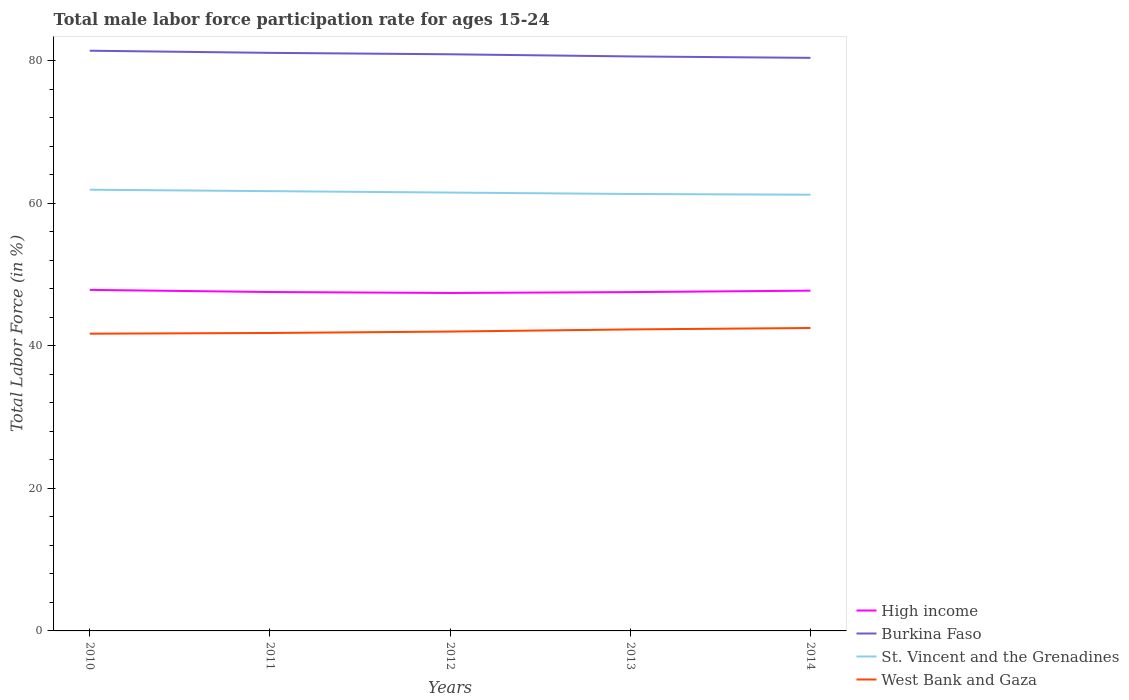Is the number of lines equal to the number of legend labels?
Keep it short and to the point. Yes. Across all years, what is the maximum male labor force participation rate in High income?
Provide a succinct answer. 47.41. In which year was the male labor force participation rate in St. Vincent and the Grenadines maximum?
Your answer should be very brief. 2014. What is the total male labor force participation rate in High income in the graph?
Provide a short and direct response. -0.19. What is the difference between the highest and the second highest male labor force participation rate in High income?
Keep it short and to the point. 0.44. What is the difference between the highest and the lowest male labor force participation rate in St. Vincent and the Grenadines?
Keep it short and to the point. 2. Is the male labor force participation rate in Burkina Faso strictly greater than the male labor force participation rate in High income over the years?
Offer a terse response. No. What is the difference between two consecutive major ticks on the Y-axis?
Keep it short and to the point. 20. Does the graph contain any zero values?
Your answer should be very brief. No. How many legend labels are there?
Your answer should be very brief. 4. What is the title of the graph?
Provide a succinct answer. Total male labor force participation rate for ages 15-24. Does "East Asia (developing only)" appear as one of the legend labels in the graph?
Your answer should be compact. No. What is the Total Labor Force (in %) in High income in 2010?
Offer a terse response. 47.85. What is the Total Labor Force (in %) of Burkina Faso in 2010?
Make the answer very short. 81.4. What is the Total Labor Force (in %) in St. Vincent and the Grenadines in 2010?
Provide a short and direct response. 61.9. What is the Total Labor Force (in %) of West Bank and Gaza in 2010?
Give a very brief answer. 41.7. What is the Total Labor Force (in %) in High income in 2011?
Provide a short and direct response. 47.55. What is the Total Labor Force (in %) of Burkina Faso in 2011?
Provide a succinct answer. 81.1. What is the Total Labor Force (in %) of St. Vincent and the Grenadines in 2011?
Make the answer very short. 61.7. What is the Total Labor Force (in %) of West Bank and Gaza in 2011?
Make the answer very short. 41.8. What is the Total Labor Force (in %) in High income in 2012?
Keep it short and to the point. 47.41. What is the Total Labor Force (in %) in Burkina Faso in 2012?
Your answer should be compact. 80.9. What is the Total Labor Force (in %) of St. Vincent and the Grenadines in 2012?
Make the answer very short. 61.5. What is the Total Labor Force (in %) of West Bank and Gaza in 2012?
Provide a short and direct response. 42. What is the Total Labor Force (in %) of High income in 2013?
Provide a short and direct response. 47.53. What is the Total Labor Force (in %) in Burkina Faso in 2013?
Provide a succinct answer. 80.6. What is the Total Labor Force (in %) of St. Vincent and the Grenadines in 2013?
Keep it short and to the point. 61.3. What is the Total Labor Force (in %) of West Bank and Gaza in 2013?
Your response must be concise. 42.3. What is the Total Labor Force (in %) in High income in 2014?
Keep it short and to the point. 47.74. What is the Total Labor Force (in %) in Burkina Faso in 2014?
Provide a succinct answer. 80.4. What is the Total Labor Force (in %) of St. Vincent and the Grenadines in 2014?
Your answer should be compact. 61.2. What is the Total Labor Force (in %) of West Bank and Gaza in 2014?
Offer a terse response. 42.5. Across all years, what is the maximum Total Labor Force (in %) in High income?
Ensure brevity in your answer.  47.85. Across all years, what is the maximum Total Labor Force (in %) in Burkina Faso?
Give a very brief answer. 81.4. Across all years, what is the maximum Total Labor Force (in %) of St. Vincent and the Grenadines?
Make the answer very short. 61.9. Across all years, what is the maximum Total Labor Force (in %) of West Bank and Gaza?
Make the answer very short. 42.5. Across all years, what is the minimum Total Labor Force (in %) in High income?
Offer a very short reply. 47.41. Across all years, what is the minimum Total Labor Force (in %) in Burkina Faso?
Make the answer very short. 80.4. Across all years, what is the minimum Total Labor Force (in %) of St. Vincent and the Grenadines?
Your answer should be very brief. 61.2. Across all years, what is the minimum Total Labor Force (in %) in West Bank and Gaza?
Your answer should be very brief. 41.7. What is the total Total Labor Force (in %) of High income in the graph?
Ensure brevity in your answer.  238.08. What is the total Total Labor Force (in %) of Burkina Faso in the graph?
Offer a very short reply. 404.4. What is the total Total Labor Force (in %) of St. Vincent and the Grenadines in the graph?
Your response must be concise. 307.6. What is the total Total Labor Force (in %) in West Bank and Gaza in the graph?
Provide a short and direct response. 210.3. What is the difference between the Total Labor Force (in %) of High income in 2010 and that in 2011?
Offer a very short reply. 0.3. What is the difference between the Total Labor Force (in %) of Burkina Faso in 2010 and that in 2011?
Your answer should be very brief. 0.3. What is the difference between the Total Labor Force (in %) in West Bank and Gaza in 2010 and that in 2011?
Ensure brevity in your answer.  -0.1. What is the difference between the Total Labor Force (in %) in High income in 2010 and that in 2012?
Provide a succinct answer. 0.44. What is the difference between the Total Labor Force (in %) in St. Vincent and the Grenadines in 2010 and that in 2012?
Your response must be concise. 0.4. What is the difference between the Total Labor Force (in %) of West Bank and Gaza in 2010 and that in 2012?
Offer a terse response. -0.3. What is the difference between the Total Labor Force (in %) in High income in 2010 and that in 2013?
Make the answer very short. 0.31. What is the difference between the Total Labor Force (in %) of Burkina Faso in 2010 and that in 2013?
Your answer should be compact. 0.8. What is the difference between the Total Labor Force (in %) in St. Vincent and the Grenadines in 2010 and that in 2013?
Your response must be concise. 0.6. What is the difference between the Total Labor Force (in %) in High income in 2010 and that in 2014?
Offer a terse response. 0.11. What is the difference between the Total Labor Force (in %) of St. Vincent and the Grenadines in 2010 and that in 2014?
Your answer should be very brief. 0.7. What is the difference between the Total Labor Force (in %) of High income in 2011 and that in 2012?
Offer a very short reply. 0.13. What is the difference between the Total Labor Force (in %) of Burkina Faso in 2011 and that in 2012?
Your answer should be very brief. 0.2. What is the difference between the Total Labor Force (in %) in West Bank and Gaza in 2011 and that in 2012?
Ensure brevity in your answer.  -0.2. What is the difference between the Total Labor Force (in %) in High income in 2011 and that in 2013?
Your answer should be very brief. 0.01. What is the difference between the Total Labor Force (in %) in High income in 2011 and that in 2014?
Give a very brief answer. -0.19. What is the difference between the Total Labor Force (in %) in Burkina Faso in 2011 and that in 2014?
Your response must be concise. 0.7. What is the difference between the Total Labor Force (in %) of High income in 2012 and that in 2013?
Offer a terse response. -0.12. What is the difference between the Total Labor Force (in %) of Burkina Faso in 2012 and that in 2013?
Give a very brief answer. 0.3. What is the difference between the Total Labor Force (in %) in West Bank and Gaza in 2012 and that in 2013?
Offer a terse response. -0.3. What is the difference between the Total Labor Force (in %) of High income in 2012 and that in 2014?
Your response must be concise. -0.33. What is the difference between the Total Labor Force (in %) in Burkina Faso in 2012 and that in 2014?
Make the answer very short. 0.5. What is the difference between the Total Labor Force (in %) in West Bank and Gaza in 2012 and that in 2014?
Keep it short and to the point. -0.5. What is the difference between the Total Labor Force (in %) of High income in 2013 and that in 2014?
Keep it short and to the point. -0.2. What is the difference between the Total Labor Force (in %) in West Bank and Gaza in 2013 and that in 2014?
Your answer should be compact. -0.2. What is the difference between the Total Labor Force (in %) of High income in 2010 and the Total Labor Force (in %) of Burkina Faso in 2011?
Your response must be concise. -33.25. What is the difference between the Total Labor Force (in %) of High income in 2010 and the Total Labor Force (in %) of St. Vincent and the Grenadines in 2011?
Offer a terse response. -13.85. What is the difference between the Total Labor Force (in %) in High income in 2010 and the Total Labor Force (in %) in West Bank and Gaza in 2011?
Make the answer very short. 6.05. What is the difference between the Total Labor Force (in %) in Burkina Faso in 2010 and the Total Labor Force (in %) in St. Vincent and the Grenadines in 2011?
Provide a succinct answer. 19.7. What is the difference between the Total Labor Force (in %) in Burkina Faso in 2010 and the Total Labor Force (in %) in West Bank and Gaza in 2011?
Offer a terse response. 39.6. What is the difference between the Total Labor Force (in %) of St. Vincent and the Grenadines in 2010 and the Total Labor Force (in %) of West Bank and Gaza in 2011?
Offer a very short reply. 20.1. What is the difference between the Total Labor Force (in %) of High income in 2010 and the Total Labor Force (in %) of Burkina Faso in 2012?
Give a very brief answer. -33.05. What is the difference between the Total Labor Force (in %) of High income in 2010 and the Total Labor Force (in %) of St. Vincent and the Grenadines in 2012?
Provide a succinct answer. -13.65. What is the difference between the Total Labor Force (in %) in High income in 2010 and the Total Labor Force (in %) in West Bank and Gaza in 2012?
Ensure brevity in your answer.  5.85. What is the difference between the Total Labor Force (in %) of Burkina Faso in 2010 and the Total Labor Force (in %) of West Bank and Gaza in 2012?
Offer a terse response. 39.4. What is the difference between the Total Labor Force (in %) of St. Vincent and the Grenadines in 2010 and the Total Labor Force (in %) of West Bank and Gaza in 2012?
Offer a very short reply. 19.9. What is the difference between the Total Labor Force (in %) of High income in 2010 and the Total Labor Force (in %) of Burkina Faso in 2013?
Ensure brevity in your answer.  -32.75. What is the difference between the Total Labor Force (in %) of High income in 2010 and the Total Labor Force (in %) of St. Vincent and the Grenadines in 2013?
Make the answer very short. -13.45. What is the difference between the Total Labor Force (in %) in High income in 2010 and the Total Labor Force (in %) in West Bank and Gaza in 2013?
Your answer should be very brief. 5.55. What is the difference between the Total Labor Force (in %) in Burkina Faso in 2010 and the Total Labor Force (in %) in St. Vincent and the Grenadines in 2013?
Ensure brevity in your answer.  20.1. What is the difference between the Total Labor Force (in %) of Burkina Faso in 2010 and the Total Labor Force (in %) of West Bank and Gaza in 2013?
Ensure brevity in your answer.  39.1. What is the difference between the Total Labor Force (in %) in St. Vincent and the Grenadines in 2010 and the Total Labor Force (in %) in West Bank and Gaza in 2013?
Offer a terse response. 19.6. What is the difference between the Total Labor Force (in %) of High income in 2010 and the Total Labor Force (in %) of Burkina Faso in 2014?
Your answer should be compact. -32.55. What is the difference between the Total Labor Force (in %) of High income in 2010 and the Total Labor Force (in %) of St. Vincent and the Grenadines in 2014?
Make the answer very short. -13.35. What is the difference between the Total Labor Force (in %) in High income in 2010 and the Total Labor Force (in %) in West Bank and Gaza in 2014?
Make the answer very short. 5.35. What is the difference between the Total Labor Force (in %) of Burkina Faso in 2010 and the Total Labor Force (in %) of St. Vincent and the Grenadines in 2014?
Keep it short and to the point. 20.2. What is the difference between the Total Labor Force (in %) of Burkina Faso in 2010 and the Total Labor Force (in %) of West Bank and Gaza in 2014?
Provide a short and direct response. 38.9. What is the difference between the Total Labor Force (in %) of High income in 2011 and the Total Labor Force (in %) of Burkina Faso in 2012?
Offer a very short reply. -33.35. What is the difference between the Total Labor Force (in %) in High income in 2011 and the Total Labor Force (in %) in St. Vincent and the Grenadines in 2012?
Keep it short and to the point. -13.95. What is the difference between the Total Labor Force (in %) in High income in 2011 and the Total Labor Force (in %) in West Bank and Gaza in 2012?
Provide a succinct answer. 5.55. What is the difference between the Total Labor Force (in %) in Burkina Faso in 2011 and the Total Labor Force (in %) in St. Vincent and the Grenadines in 2012?
Provide a short and direct response. 19.6. What is the difference between the Total Labor Force (in %) in Burkina Faso in 2011 and the Total Labor Force (in %) in West Bank and Gaza in 2012?
Your answer should be very brief. 39.1. What is the difference between the Total Labor Force (in %) in St. Vincent and the Grenadines in 2011 and the Total Labor Force (in %) in West Bank and Gaza in 2012?
Offer a very short reply. 19.7. What is the difference between the Total Labor Force (in %) in High income in 2011 and the Total Labor Force (in %) in Burkina Faso in 2013?
Offer a very short reply. -33.05. What is the difference between the Total Labor Force (in %) of High income in 2011 and the Total Labor Force (in %) of St. Vincent and the Grenadines in 2013?
Make the answer very short. -13.75. What is the difference between the Total Labor Force (in %) in High income in 2011 and the Total Labor Force (in %) in West Bank and Gaza in 2013?
Your answer should be compact. 5.25. What is the difference between the Total Labor Force (in %) of Burkina Faso in 2011 and the Total Labor Force (in %) of St. Vincent and the Grenadines in 2013?
Provide a succinct answer. 19.8. What is the difference between the Total Labor Force (in %) in Burkina Faso in 2011 and the Total Labor Force (in %) in West Bank and Gaza in 2013?
Provide a short and direct response. 38.8. What is the difference between the Total Labor Force (in %) of St. Vincent and the Grenadines in 2011 and the Total Labor Force (in %) of West Bank and Gaza in 2013?
Offer a very short reply. 19.4. What is the difference between the Total Labor Force (in %) of High income in 2011 and the Total Labor Force (in %) of Burkina Faso in 2014?
Provide a succinct answer. -32.85. What is the difference between the Total Labor Force (in %) in High income in 2011 and the Total Labor Force (in %) in St. Vincent and the Grenadines in 2014?
Your response must be concise. -13.65. What is the difference between the Total Labor Force (in %) in High income in 2011 and the Total Labor Force (in %) in West Bank and Gaza in 2014?
Offer a terse response. 5.05. What is the difference between the Total Labor Force (in %) in Burkina Faso in 2011 and the Total Labor Force (in %) in West Bank and Gaza in 2014?
Your answer should be compact. 38.6. What is the difference between the Total Labor Force (in %) in St. Vincent and the Grenadines in 2011 and the Total Labor Force (in %) in West Bank and Gaza in 2014?
Your response must be concise. 19.2. What is the difference between the Total Labor Force (in %) in High income in 2012 and the Total Labor Force (in %) in Burkina Faso in 2013?
Keep it short and to the point. -33.19. What is the difference between the Total Labor Force (in %) of High income in 2012 and the Total Labor Force (in %) of St. Vincent and the Grenadines in 2013?
Offer a terse response. -13.89. What is the difference between the Total Labor Force (in %) of High income in 2012 and the Total Labor Force (in %) of West Bank and Gaza in 2013?
Your response must be concise. 5.11. What is the difference between the Total Labor Force (in %) in Burkina Faso in 2012 and the Total Labor Force (in %) in St. Vincent and the Grenadines in 2013?
Your answer should be compact. 19.6. What is the difference between the Total Labor Force (in %) of Burkina Faso in 2012 and the Total Labor Force (in %) of West Bank and Gaza in 2013?
Provide a succinct answer. 38.6. What is the difference between the Total Labor Force (in %) in St. Vincent and the Grenadines in 2012 and the Total Labor Force (in %) in West Bank and Gaza in 2013?
Ensure brevity in your answer.  19.2. What is the difference between the Total Labor Force (in %) of High income in 2012 and the Total Labor Force (in %) of Burkina Faso in 2014?
Your answer should be compact. -32.99. What is the difference between the Total Labor Force (in %) of High income in 2012 and the Total Labor Force (in %) of St. Vincent and the Grenadines in 2014?
Your answer should be compact. -13.79. What is the difference between the Total Labor Force (in %) in High income in 2012 and the Total Labor Force (in %) in West Bank and Gaza in 2014?
Ensure brevity in your answer.  4.91. What is the difference between the Total Labor Force (in %) of Burkina Faso in 2012 and the Total Labor Force (in %) of St. Vincent and the Grenadines in 2014?
Provide a succinct answer. 19.7. What is the difference between the Total Labor Force (in %) in Burkina Faso in 2012 and the Total Labor Force (in %) in West Bank and Gaza in 2014?
Your response must be concise. 38.4. What is the difference between the Total Labor Force (in %) of St. Vincent and the Grenadines in 2012 and the Total Labor Force (in %) of West Bank and Gaza in 2014?
Make the answer very short. 19. What is the difference between the Total Labor Force (in %) of High income in 2013 and the Total Labor Force (in %) of Burkina Faso in 2014?
Provide a succinct answer. -32.87. What is the difference between the Total Labor Force (in %) of High income in 2013 and the Total Labor Force (in %) of St. Vincent and the Grenadines in 2014?
Give a very brief answer. -13.67. What is the difference between the Total Labor Force (in %) of High income in 2013 and the Total Labor Force (in %) of West Bank and Gaza in 2014?
Keep it short and to the point. 5.03. What is the difference between the Total Labor Force (in %) in Burkina Faso in 2013 and the Total Labor Force (in %) in St. Vincent and the Grenadines in 2014?
Ensure brevity in your answer.  19.4. What is the difference between the Total Labor Force (in %) in Burkina Faso in 2013 and the Total Labor Force (in %) in West Bank and Gaza in 2014?
Provide a succinct answer. 38.1. What is the average Total Labor Force (in %) of High income per year?
Offer a very short reply. 47.62. What is the average Total Labor Force (in %) of Burkina Faso per year?
Provide a succinct answer. 80.88. What is the average Total Labor Force (in %) in St. Vincent and the Grenadines per year?
Offer a terse response. 61.52. What is the average Total Labor Force (in %) of West Bank and Gaza per year?
Your response must be concise. 42.06. In the year 2010, what is the difference between the Total Labor Force (in %) of High income and Total Labor Force (in %) of Burkina Faso?
Your answer should be very brief. -33.55. In the year 2010, what is the difference between the Total Labor Force (in %) in High income and Total Labor Force (in %) in St. Vincent and the Grenadines?
Give a very brief answer. -14.05. In the year 2010, what is the difference between the Total Labor Force (in %) in High income and Total Labor Force (in %) in West Bank and Gaza?
Give a very brief answer. 6.15. In the year 2010, what is the difference between the Total Labor Force (in %) of Burkina Faso and Total Labor Force (in %) of St. Vincent and the Grenadines?
Keep it short and to the point. 19.5. In the year 2010, what is the difference between the Total Labor Force (in %) of Burkina Faso and Total Labor Force (in %) of West Bank and Gaza?
Provide a succinct answer. 39.7. In the year 2010, what is the difference between the Total Labor Force (in %) of St. Vincent and the Grenadines and Total Labor Force (in %) of West Bank and Gaza?
Ensure brevity in your answer.  20.2. In the year 2011, what is the difference between the Total Labor Force (in %) in High income and Total Labor Force (in %) in Burkina Faso?
Provide a short and direct response. -33.55. In the year 2011, what is the difference between the Total Labor Force (in %) in High income and Total Labor Force (in %) in St. Vincent and the Grenadines?
Your answer should be very brief. -14.15. In the year 2011, what is the difference between the Total Labor Force (in %) of High income and Total Labor Force (in %) of West Bank and Gaza?
Your answer should be compact. 5.75. In the year 2011, what is the difference between the Total Labor Force (in %) in Burkina Faso and Total Labor Force (in %) in St. Vincent and the Grenadines?
Your response must be concise. 19.4. In the year 2011, what is the difference between the Total Labor Force (in %) in Burkina Faso and Total Labor Force (in %) in West Bank and Gaza?
Ensure brevity in your answer.  39.3. In the year 2012, what is the difference between the Total Labor Force (in %) in High income and Total Labor Force (in %) in Burkina Faso?
Offer a very short reply. -33.49. In the year 2012, what is the difference between the Total Labor Force (in %) of High income and Total Labor Force (in %) of St. Vincent and the Grenadines?
Your answer should be very brief. -14.09. In the year 2012, what is the difference between the Total Labor Force (in %) of High income and Total Labor Force (in %) of West Bank and Gaza?
Offer a terse response. 5.41. In the year 2012, what is the difference between the Total Labor Force (in %) of Burkina Faso and Total Labor Force (in %) of St. Vincent and the Grenadines?
Provide a succinct answer. 19.4. In the year 2012, what is the difference between the Total Labor Force (in %) in Burkina Faso and Total Labor Force (in %) in West Bank and Gaza?
Keep it short and to the point. 38.9. In the year 2012, what is the difference between the Total Labor Force (in %) in St. Vincent and the Grenadines and Total Labor Force (in %) in West Bank and Gaza?
Offer a terse response. 19.5. In the year 2013, what is the difference between the Total Labor Force (in %) of High income and Total Labor Force (in %) of Burkina Faso?
Make the answer very short. -33.07. In the year 2013, what is the difference between the Total Labor Force (in %) of High income and Total Labor Force (in %) of St. Vincent and the Grenadines?
Give a very brief answer. -13.77. In the year 2013, what is the difference between the Total Labor Force (in %) of High income and Total Labor Force (in %) of West Bank and Gaza?
Your answer should be very brief. 5.23. In the year 2013, what is the difference between the Total Labor Force (in %) in Burkina Faso and Total Labor Force (in %) in St. Vincent and the Grenadines?
Provide a short and direct response. 19.3. In the year 2013, what is the difference between the Total Labor Force (in %) of Burkina Faso and Total Labor Force (in %) of West Bank and Gaza?
Your answer should be very brief. 38.3. In the year 2014, what is the difference between the Total Labor Force (in %) in High income and Total Labor Force (in %) in Burkina Faso?
Ensure brevity in your answer.  -32.66. In the year 2014, what is the difference between the Total Labor Force (in %) in High income and Total Labor Force (in %) in St. Vincent and the Grenadines?
Offer a very short reply. -13.46. In the year 2014, what is the difference between the Total Labor Force (in %) in High income and Total Labor Force (in %) in West Bank and Gaza?
Your answer should be compact. 5.24. In the year 2014, what is the difference between the Total Labor Force (in %) in Burkina Faso and Total Labor Force (in %) in West Bank and Gaza?
Your answer should be very brief. 37.9. In the year 2014, what is the difference between the Total Labor Force (in %) in St. Vincent and the Grenadines and Total Labor Force (in %) in West Bank and Gaza?
Your response must be concise. 18.7. What is the ratio of the Total Labor Force (in %) of Burkina Faso in 2010 to that in 2011?
Offer a terse response. 1. What is the ratio of the Total Labor Force (in %) of West Bank and Gaza in 2010 to that in 2011?
Ensure brevity in your answer.  1. What is the ratio of the Total Labor Force (in %) of High income in 2010 to that in 2012?
Your answer should be very brief. 1.01. What is the ratio of the Total Labor Force (in %) of Burkina Faso in 2010 to that in 2012?
Keep it short and to the point. 1.01. What is the ratio of the Total Labor Force (in %) in West Bank and Gaza in 2010 to that in 2012?
Offer a very short reply. 0.99. What is the ratio of the Total Labor Force (in %) of High income in 2010 to that in 2013?
Offer a terse response. 1.01. What is the ratio of the Total Labor Force (in %) of Burkina Faso in 2010 to that in 2013?
Keep it short and to the point. 1.01. What is the ratio of the Total Labor Force (in %) in St. Vincent and the Grenadines in 2010 to that in 2013?
Provide a short and direct response. 1.01. What is the ratio of the Total Labor Force (in %) of West Bank and Gaza in 2010 to that in 2013?
Provide a short and direct response. 0.99. What is the ratio of the Total Labor Force (in %) in High income in 2010 to that in 2014?
Give a very brief answer. 1. What is the ratio of the Total Labor Force (in %) of Burkina Faso in 2010 to that in 2014?
Give a very brief answer. 1.01. What is the ratio of the Total Labor Force (in %) of St. Vincent and the Grenadines in 2010 to that in 2014?
Your answer should be very brief. 1.01. What is the ratio of the Total Labor Force (in %) in West Bank and Gaza in 2010 to that in 2014?
Provide a short and direct response. 0.98. What is the ratio of the Total Labor Force (in %) of St. Vincent and the Grenadines in 2011 to that in 2012?
Make the answer very short. 1. What is the ratio of the Total Labor Force (in %) of West Bank and Gaza in 2011 to that in 2012?
Keep it short and to the point. 1. What is the ratio of the Total Labor Force (in %) of High income in 2011 to that in 2013?
Offer a very short reply. 1. What is the ratio of the Total Labor Force (in %) in St. Vincent and the Grenadines in 2011 to that in 2013?
Your answer should be compact. 1.01. What is the ratio of the Total Labor Force (in %) in West Bank and Gaza in 2011 to that in 2013?
Provide a succinct answer. 0.99. What is the ratio of the Total Labor Force (in %) of Burkina Faso in 2011 to that in 2014?
Your response must be concise. 1.01. What is the ratio of the Total Labor Force (in %) in St. Vincent and the Grenadines in 2011 to that in 2014?
Ensure brevity in your answer.  1.01. What is the ratio of the Total Labor Force (in %) in West Bank and Gaza in 2011 to that in 2014?
Your answer should be compact. 0.98. What is the ratio of the Total Labor Force (in %) of Burkina Faso in 2012 to that in 2013?
Give a very brief answer. 1. What is the ratio of the Total Labor Force (in %) in St. Vincent and the Grenadines in 2012 to that in 2013?
Provide a succinct answer. 1. What is the ratio of the Total Labor Force (in %) of West Bank and Gaza in 2012 to that in 2013?
Offer a very short reply. 0.99. What is the ratio of the Total Labor Force (in %) in High income in 2012 to that in 2014?
Keep it short and to the point. 0.99. What is the ratio of the Total Labor Force (in %) of West Bank and Gaza in 2012 to that in 2014?
Provide a short and direct response. 0.99. What is the ratio of the Total Labor Force (in %) of High income in 2013 to that in 2014?
Give a very brief answer. 1. What is the ratio of the Total Labor Force (in %) of Burkina Faso in 2013 to that in 2014?
Offer a terse response. 1. What is the ratio of the Total Labor Force (in %) of St. Vincent and the Grenadines in 2013 to that in 2014?
Your response must be concise. 1. What is the ratio of the Total Labor Force (in %) in West Bank and Gaza in 2013 to that in 2014?
Provide a short and direct response. 1. What is the difference between the highest and the second highest Total Labor Force (in %) in High income?
Offer a very short reply. 0.11. What is the difference between the highest and the lowest Total Labor Force (in %) in High income?
Your response must be concise. 0.44. What is the difference between the highest and the lowest Total Labor Force (in %) in Burkina Faso?
Your answer should be very brief. 1. What is the difference between the highest and the lowest Total Labor Force (in %) of West Bank and Gaza?
Provide a short and direct response. 0.8. 